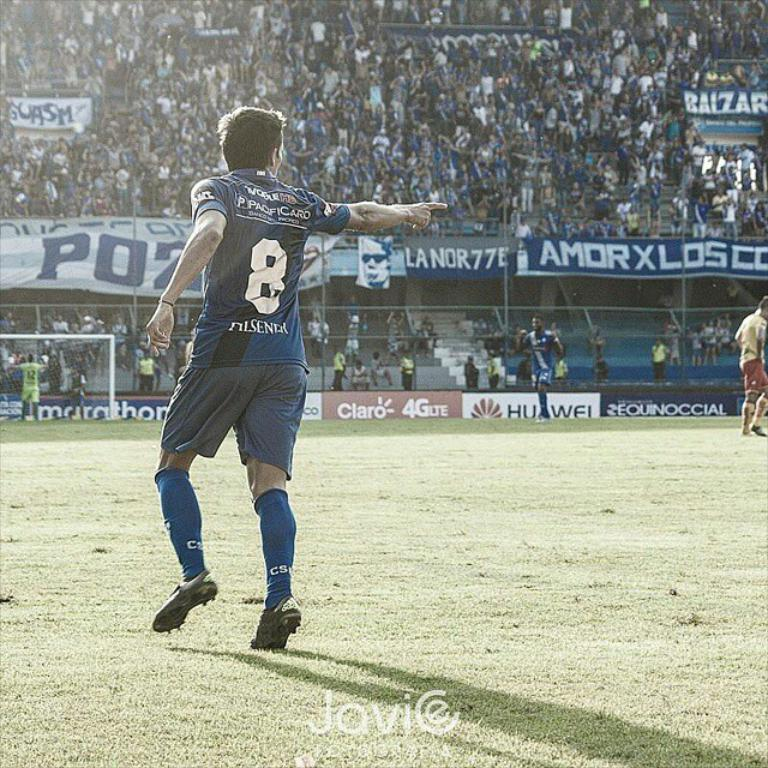<image>
Summarize the visual content of the image. Player wearing number 8 pointing to something while on the field. 